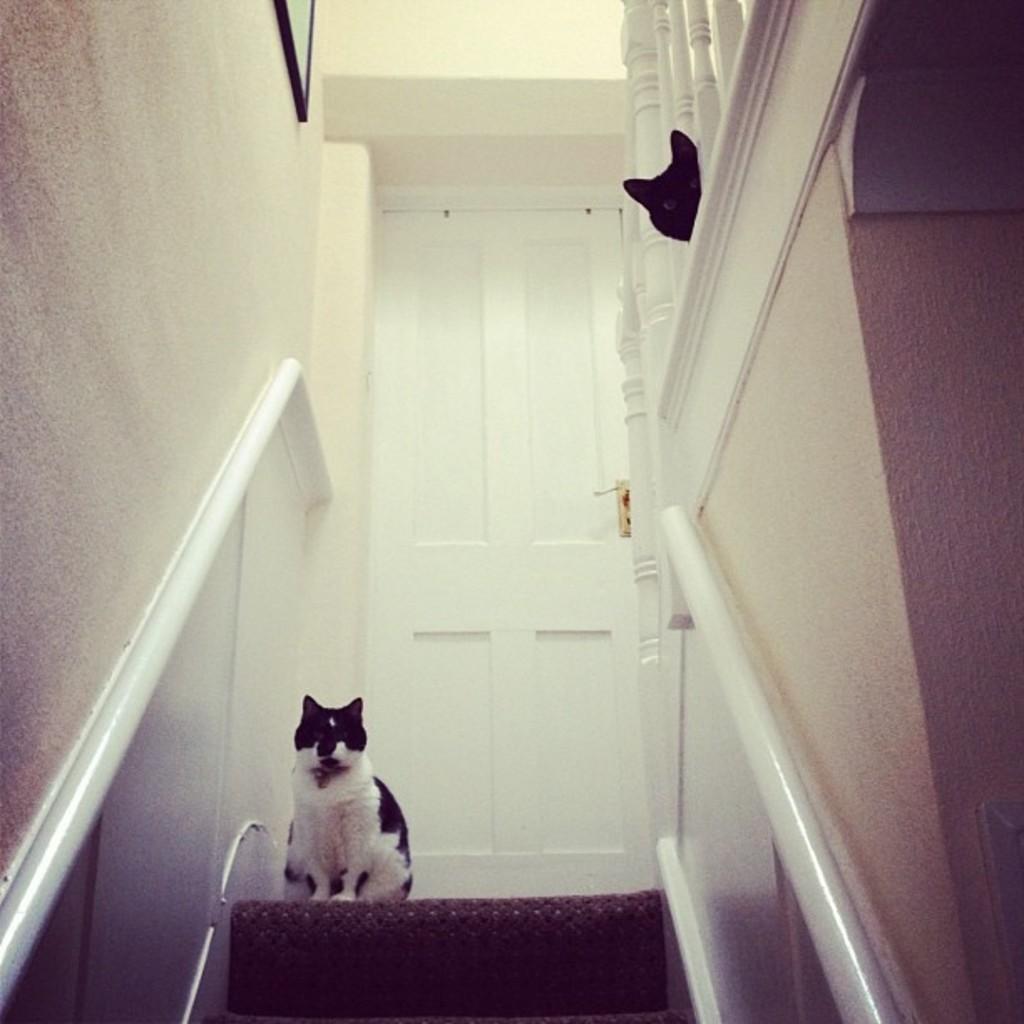Please provide a concise description of this image. The picture is taken in a house. In the foreground of the picture there is a staircase, on the staircase there is a cat. In the background there is a door. On the right there is a cat and railing. On the left there is a wall painted white and a frame. 